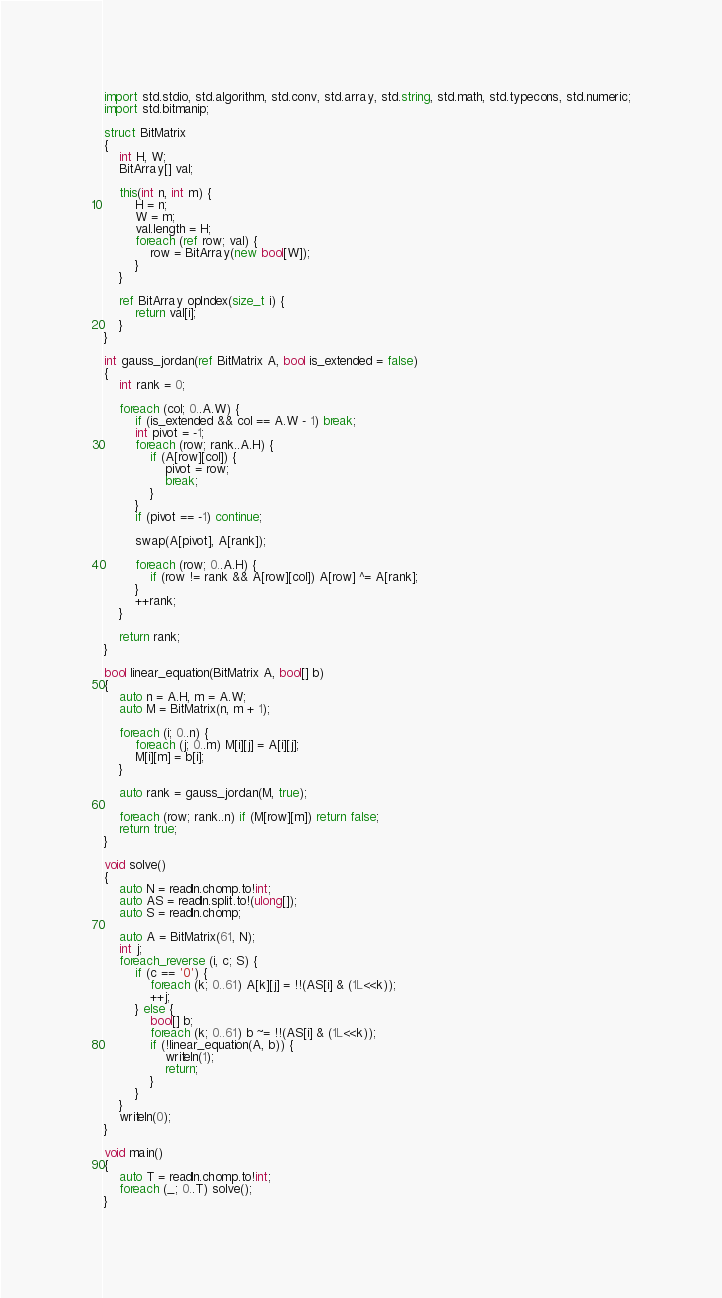Convert code to text. <code><loc_0><loc_0><loc_500><loc_500><_D_>import std.stdio, std.algorithm, std.conv, std.array, std.string, std.math, std.typecons, std.numeric;
import std.bitmanip;

struct BitMatrix
{
    int H, W;
    BitArray[] val;

    this(int n, int m) {
        H = n;
        W = m;
        val.length = H;
        foreach (ref row; val) {
            row = BitArray(new bool[W]);
        }
    }

    ref BitArray opIndex(size_t i) {
        return val[i];
    }
}

int gauss_jordan(ref BitMatrix A, bool is_extended = false)
{
    int rank = 0;

    foreach (col; 0..A.W) {
        if (is_extended && col == A.W - 1) break;
        int pivot = -1;
        foreach (row; rank..A.H) {
            if (A[row][col]) {
                pivot = row;
                break;
            }
        }
        if (pivot == -1) continue;

        swap(A[pivot], A[rank]);

        foreach (row; 0..A.H) {
            if (row != rank && A[row][col]) A[row] ^= A[rank];
        }
        ++rank;
    }

    return rank;
}

bool linear_equation(BitMatrix A, bool[] b)
{
    auto n = A.H, m = A.W;
    auto M = BitMatrix(n, m + 1);

    foreach (i; 0..n) {
        foreach (j; 0..m) M[i][j] = A[i][j];
        M[i][m] = b[i];
    }

    auto rank = gauss_jordan(M, true);

    foreach (row; rank..n) if (M[row][m]) return false;
    return true;
}

void solve()
{
    auto N = readln.chomp.to!int;
    auto AS = readln.split.to!(ulong[]);
    auto S = readln.chomp;

    auto A = BitMatrix(61, N);
    int j;
    foreach_reverse (i, c; S) {
        if (c == '0') {
            foreach (k; 0..61) A[k][j] = !!(AS[i] & (1L<<k));
            ++j;
        } else {
            bool[] b;
            foreach (k; 0..61) b ~= !!(AS[i] & (1L<<k));
            if (!linear_equation(A, b)) {
                writeln(1);
                return;
            }
        }
    }
    writeln(0);
}

void main()
{
    auto T = readln.chomp.to!int;
    foreach (_; 0..T) solve();
}</code> 